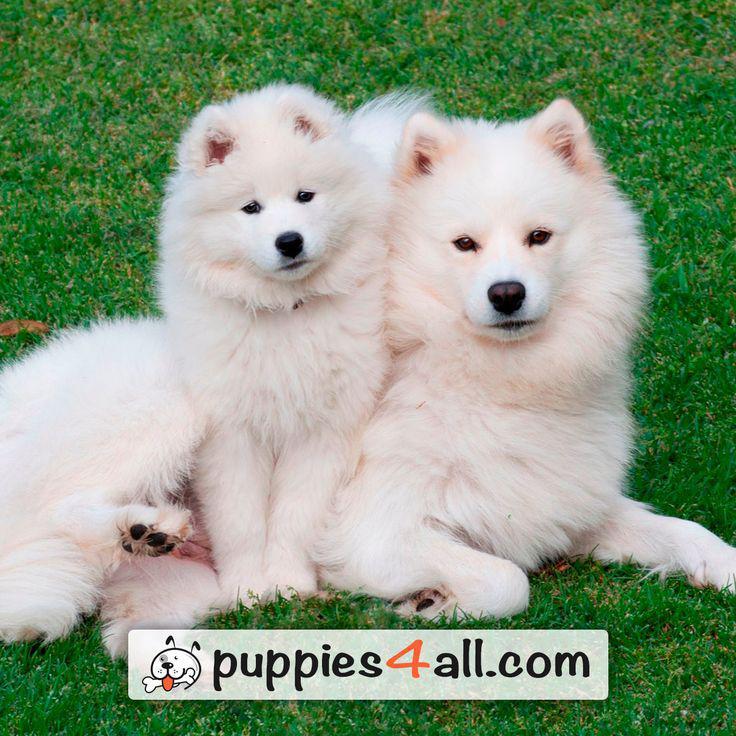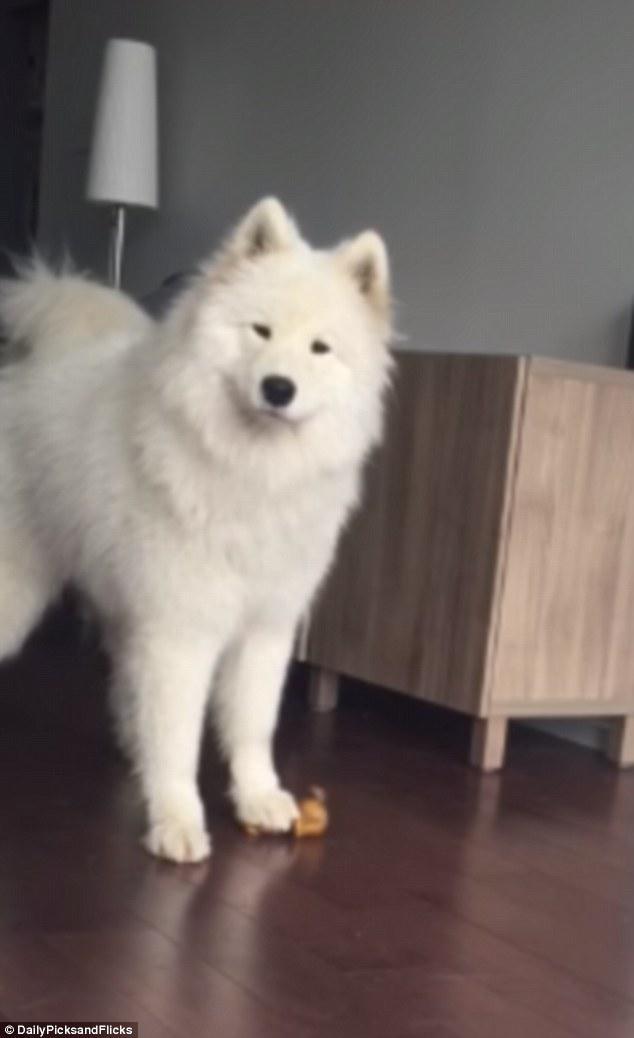The first image is the image on the left, the second image is the image on the right. Considering the images on both sides, is "There are no more then two white dogs." valid? Answer yes or no. No. The first image is the image on the left, the second image is the image on the right. Analyze the images presented: Is the assertion "An image shows a young white dog next to a reclining large white dog on bright green grass." valid? Answer yes or no. Yes. 